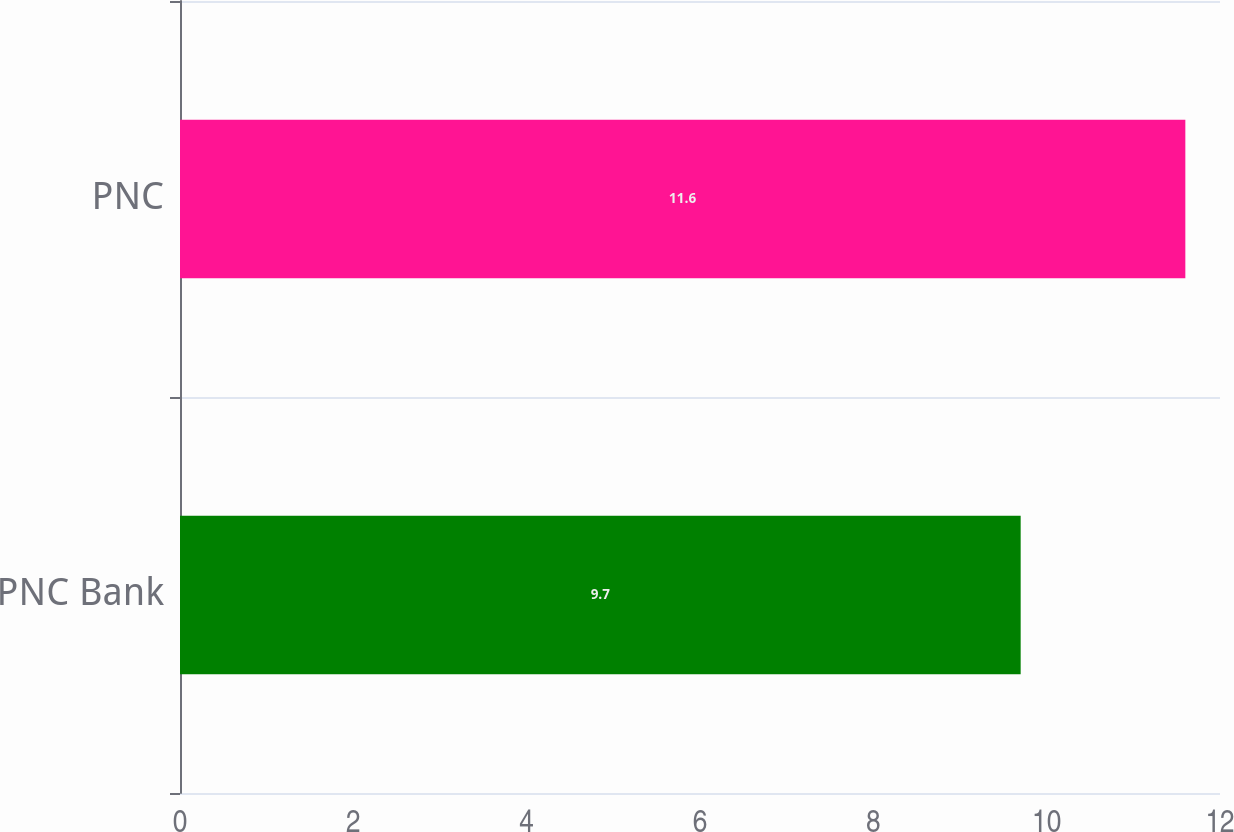Convert chart. <chart><loc_0><loc_0><loc_500><loc_500><bar_chart><fcel>PNC Bank<fcel>PNC<nl><fcel>9.7<fcel>11.6<nl></chart> 